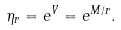Convert formula to latex. <formula><loc_0><loc_0><loc_500><loc_500>\eta _ { r } = e ^ { V } = e ^ { M / r } .</formula> 